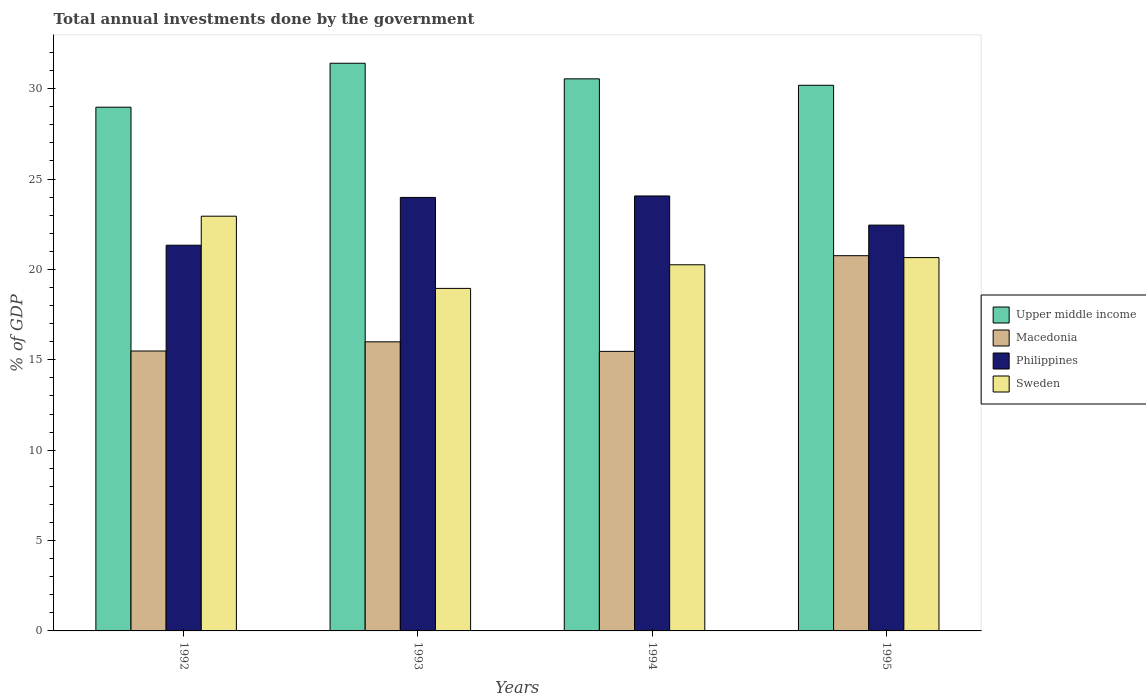How many groups of bars are there?
Provide a succinct answer. 4. Are the number of bars on each tick of the X-axis equal?
Provide a short and direct response. Yes. How many bars are there on the 4th tick from the right?
Your response must be concise. 4. What is the label of the 3rd group of bars from the left?
Your answer should be compact. 1994. What is the total annual investments done by the government in Philippines in 1993?
Make the answer very short. 23.98. Across all years, what is the maximum total annual investments done by the government in Upper middle income?
Offer a very short reply. 31.4. Across all years, what is the minimum total annual investments done by the government in Sweden?
Offer a very short reply. 18.95. In which year was the total annual investments done by the government in Sweden maximum?
Give a very brief answer. 1992. What is the total total annual investments done by the government in Sweden in the graph?
Offer a very short reply. 82.8. What is the difference between the total annual investments done by the government in Upper middle income in 1992 and that in 1994?
Ensure brevity in your answer.  -1.57. What is the difference between the total annual investments done by the government in Sweden in 1993 and the total annual investments done by the government in Upper middle income in 1995?
Keep it short and to the point. -11.24. What is the average total annual investments done by the government in Sweden per year?
Make the answer very short. 20.7. In the year 1995, what is the difference between the total annual investments done by the government in Upper middle income and total annual investments done by the government in Macedonia?
Your answer should be very brief. 9.43. In how many years, is the total annual investments done by the government in Sweden greater than 19 %?
Provide a short and direct response. 3. What is the ratio of the total annual investments done by the government in Macedonia in 1993 to that in 1995?
Provide a succinct answer. 0.77. Is the difference between the total annual investments done by the government in Upper middle income in 1992 and 1993 greater than the difference between the total annual investments done by the government in Macedonia in 1992 and 1993?
Your response must be concise. No. What is the difference between the highest and the second highest total annual investments done by the government in Upper middle income?
Offer a terse response. 0.86. What is the difference between the highest and the lowest total annual investments done by the government in Macedonia?
Make the answer very short. 5.29. In how many years, is the total annual investments done by the government in Upper middle income greater than the average total annual investments done by the government in Upper middle income taken over all years?
Keep it short and to the point. 2. What does the 1st bar from the right in 1992 represents?
Provide a short and direct response. Sweden. Is it the case that in every year, the sum of the total annual investments done by the government in Sweden and total annual investments done by the government in Macedonia is greater than the total annual investments done by the government in Philippines?
Your answer should be very brief. Yes. How many bars are there?
Ensure brevity in your answer.  16. How many years are there in the graph?
Ensure brevity in your answer.  4. What is the difference between two consecutive major ticks on the Y-axis?
Your answer should be compact. 5. Does the graph contain any zero values?
Your answer should be compact. No. What is the title of the graph?
Your answer should be compact. Total annual investments done by the government. What is the label or title of the X-axis?
Your answer should be very brief. Years. What is the label or title of the Y-axis?
Provide a short and direct response. % of GDP. What is the % of GDP of Upper middle income in 1992?
Offer a terse response. 28.97. What is the % of GDP in Macedonia in 1992?
Your answer should be compact. 15.49. What is the % of GDP of Philippines in 1992?
Give a very brief answer. 21.34. What is the % of GDP of Sweden in 1992?
Make the answer very short. 22.94. What is the % of GDP in Upper middle income in 1993?
Offer a terse response. 31.4. What is the % of GDP of Macedonia in 1993?
Your answer should be very brief. 15.99. What is the % of GDP of Philippines in 1993?
Keep it short and to the point. 23.98. What is the % of GDP in Sweden in 1993?
Keep it short and to the point. 18.95. What is the % of GDP of Upper middle income in 1994?
Your response must be concise. 30.54. What is the % of GDP in Macedonia in 1994?
Ensure brevity in your answer.  15.47. What is the % of GDP of Philippines in 1994?
Give a very brief answer. 24.06. What is the % of GDP of Sweden in 1994?
Your answer should be compact. 20.26. What is the % of GDP of Upper middle income in 1995?
Keep it short and to the point. 30.19. What is the % of GDP of Macedonia in 1995?
Offer a very short reply. 20.76. What is the % of GDP of Philippines in 1995?
Provide a short and direct response. 22.45. What is the % of GDP in Sweden in 1995?
Provide a succinct answer. 20.65. Across all years, what is the maximum % of GDP in Upper middle income?
Provide a short and direct response. 31.4. Across all years, what is the maximum % of GDP of Macedonia?
Keep it short and to the point. 20.76. Across all years, what is the maximum % of GDP of Philippines?
Your answer should be compact. 24.06. Across all years, what is the maximum % of GDP of Sweden?
Keep it short and to the point. 22.94. Across all years, what is the minimum % of GDP of Upper middle income?
Your answer should be very brief. 28.97. Across all years, what is the minimum % of GDP of Macedonia?
Your response must be concise. 15.47. Across all years, what is the minimum % of GDP in Philippines?
Your answer should be compact. 21.34. Across all years, what is the minimum % of GDP in Sweden?
Ensure brevity in your answer.  18.95. What is the total % of GDP in Upper middle income in the graph?
Give a very brief answer. 121.11. What is the total % of GDP of Macedonia in the graph?
Keep it short and to the point. 67.7. What is the total % of GDP of Philippines in the graph?
Your response must be concise. 91.83. What is the total % of GDP in Sweden in the graph?
Keep it short and to the point. 82.8. What is the difference between the % of GDP of Upper middle income in 1992 and that in 1993?
Your answer should be compact. -2.43. What is the difference between the % of GDP in Macedonia in 1992 and that in 1993?
Provide a succinct answer. -0.51. What is the difference between the % of GDP of Philippines in 1992 and that in 1993?
Offer a terse response. -2.64. What is the difference between the % of GDP of Sweden in 1992 and that in 1993?
Offer a very short reply. 4. What is the difference between the % of GDP in Upper middle income in 1992 and that in 1994?
Provide a succinct answer. -1.57. What is the difference between the % of GDP in Macedonia in 1992 and that in 1994?
Offer a terse response. 0.02. What is the difference between the % of GDP in Philippines in 1992 and that in 1994?
Your answer should be compact. -2.72. What is the difference between the % of GDP in Sweden in 1992 and that in 1994?
Your response must be concise. 2.69. What is the difference between the % of GDP in Upper middle income in 1992 and that in 1995?
Make the answer very short. -1.21. What is the difference between the % of GDP in Macedonia in 1992 and that in 1995?
Keep it short and to the point. -5.27. What is the difference between the % of GDP in Philippines in 1992 and that in 1995?
Make the answer very short. -1.11. What is the difference between the % of GDP in Sweden in 1992 and that in 1995?
Give a very brief answer. 2.29. What is the difference between the % of GDP of Upper middle income in 1993 and that in 1994?
Give a very brief answer. 0.86. What is the difference between the % of GDP of Macedonia in 1993 and that in 1994?
Provide a succinct answer. 0.53. What is the difference between the % of GDP in Philippines in 1993 and that in 1994?
Keep it short and to the point. -0.08. What is the difference between the % of GDP of Sweden in 1993 and that in 1994?
Make the answer very short. -1.31. What is the difference between the % of GDP in Upper middle income in 1993 and that in 1995?
Offer a terse response. 1.22. What is the difference between the % of GDP in Macedonia in 1993 and that in 1995?
Provide a short and direct response. -4.76. What is the difference between the % of GDP in Philippines in 1993 and that in 1995?
Keep it short and to the point. 1.53. What is the difference between the % of GDP of Sweden in 1993 and that in 1995?
Provide a succinct answer. -1.7. What is the difference between the % of GDP in Upper middle income in 1994 and that in 1995?
Your response must be concise. 0.36. What is the difference between the % of GDP of Macedonia in 1994 and that in 1995?
Give a very brief answer. -5.29. What is the difference between the % of GDP in Philippines in 1994 and that in 1995?
Provide a short and direct response. 1.61. What is the difference between the % of GDP in Sweden in 1994 and that in 1995?
Your response must be concise. -0.4. What is the difference between the % of GDP in Upper middle income in 1992 and the % of GDP in Macedonia in 1993?
Your answer should be compact. 12.98. What is the difference between the % of GDP in Upper middle income in 1992 and the % of GDP in Philippines in 1993?
Offer a terse response. 4.99. What is the difference between the % of GDP in Upper middle income in 1992 and the % of GDP in Sweden in 1993?
Your answer should be very brief. 10.02. What is the difference between the % of GDP of Macedonia in 1992 and the % of GDP of Philippines in 1993?
Make the answer very short. -8.5. What is the difference between the % of GDP of Macedonia in 1992 and the % of GDP of Sweden in 1993?
Ensure brevity in your answer.  -3.46. What is the difference between the % of GDP in Philippines in 1992 and the % of GDP in Sweden in 1993?
Provide a succinct answer. 2.39. What is the difference between the % of GDP of Upper middle income in 1992 and the % of GDP of Macedonia in 1994?
Your answer should be compact. 13.51. What is the difference between the % of GDP of Upper middle income in 1992 and the % of GDP of Philippines in 1994?
Provide a short and direct response. 4.91. What is the difference between the % of GDP in Upper middle income in 1992 and the % of GDP in Sweden in 1994?
Keep it short and to the point. 8.72. What is the difference between the % of GDP of Macedonia in 1992 and the % of GDP of Philippines in 1994?
Provide a succinct answer. -8.58. What is the difference between the % of GDP in Macedonia in 1992 and the % of GDP in Sweden in 1994?
Make the answer very short. -4.77. What is the difference between the % of GDP in Philippines in 1992 and the % of GDP in Sweden in 1994?
Offer a terse response. 1.08. What is the difference between the % of GDP in Upper middle income in 1992 and the % of GDP in Macedonia in 1995?
Give a very brief answer. 8.21. What is the difference between the % of GDP of Upper middle income in 1992 and the % of GDP of Philippines in 1995?
Your answer should be very brief. 6.52. What is the difference between the % of GDP in Upper middle income in 1992 and the % of GDP in Sweden in 1995?
Offer a terse response. 8.32. What is the difference between the % of GDP of Macedonia in 1992 and the % of GDP of Philippines in 1995?
Your response must be concise. -6.97. What is the difference between the % of GDP in Macedonia in 1992 and the % of GDP in Sweden in 1995?
Provide a succinct answer. -5.17. What is the difference between the % of GDP in Philippines in 1992 and the % of GDP in Sweden in 1995?
Make the answer very short. 0.68. What is the difference between the % of GDP of Upper middle income in 1993 and the % of GDP of Macedonia in 1994?
Give a very brief answer. 15.94. What is the difference between the % of GDP of Upper middle income in 1993 and the % of GDP of Philippines in 1994?
Ensure brevity in your answer.  7.34. What is the difference between the % of GDP in Upper middle income in 1993 and the % of GDP in Sweden in 1994?
Give a very brief answer. 11.15. What is the difference between the % of GDP in Macedonia in 1993 and the % of GDP in Philippines in 1994?
Your answer should be compact. -8.07. What is the difference between the % of GDP of Macedonia in 1993 and the % of GDP of Sweden in 1994?
Your answer should be very brief. -4.26. What is the difference between the % of GDP in Philippines in 1993 and the % of GDP in Sweden in 1994?
Give a very brief answer. 3.73. What is the difference between the % of GDP of Upper middle income in 1993 and the % of GDP of Macedonia in 1995?
Offer a terse response. 10.65. What is the difference between the % of GDP of Upper middle income in 1993 and the % of GDP of Philippines in 1995?
Make the answer very short. 8.95. What is the difference between the % of GDP in Upper middle income in 1993 and the % of GDP in Sweden in 1995?
Ensure brevity in your answer.  10.75. What is the difference between the % of GDP in Macedonia in 1993 and the % of GDP in Philippines in 1995?
Provide a short and direct response. -6.46. What is the difference between the % of GDP of Macedonia in 1993 and the % of GDP of Sweden in 1995?
Offer a terse response. -4.66. What is the difference between the % of GDP of Philippines in 1993 and the % of GDP of Sweden in 1995?
Your response must be concise. 3.33. What is the difference between the % of GDP of Upper middle income in 1994 and the % of GDP of Macedonia in 1995?
Provide a short and direct response. 9.78. What is the difference between the % of GDP of Upper middle income in 1994 and the % of GDP of Philippines in 1995?
Ensure brevity in your answer.  8.09. What is the difference between the % of GDP of Upper middle income in 1994 and the % of GDP of Sweden in 1995?
Ensure brevity in your answer.  9.89. What is the difference between the % of GDP of Macedonia in 1994 and the % of GDP of Philippines in 1995?
Provide a short and direct response. -6.98. What is the difference between the % of GDP of Macedonia in 1994 and the % of GDP of Sweden in 1995?
Make the answer very short. -5.19. What is the difference between the % of GDP in Philippines in 1994 and the % of GDP in Sweden in 1995?
Ensure brevity in your answer.  3.41. What is the average % of GDP in Upper middle income per year?
Provide a short and direct response. 30.28. What is the average % of GDP in Macedonia per year?
Make the answer very short. 16.93. What is the average % of GDP of Philippines per year?
Ensure brevity in your answer.  22.96. What is the average % of GDP of Sweden per year?
Your answer should be very brief. 20.7. In the year 1992, what is the difference between the % of GDP of Upper middle income and % of GDP of Macedonia?
Give a very brief answer. 13.49. In the year 1992, what is the difference between the % of GDP in Upper middle income and % of GDP in Philippines?
Offer a terse response. 7.63. In the year 1992, what is the difference between the % of GDP of Upper middle income and % of GDP of Sweden?
Give a very brief answer. 6.03. In the year 1992, what is the difference between the % of GDP in Macedonia and % of GDP in Philippines?
Offer a very short reply. -5.85. In the year 1992, what is the difference between the % of GDP of Macedonia and % of GDP of Sweden?
Keep it short and to the point. -7.46. In the year 1992, what is the difference between the % of GDP in Philippines and % of GDP in Sweden?
Offer a very short reply. -1.61. In the year 1993, what is the difference between the % of GDP in Upper middle income and % of GDP in Macedonia?
Your answer should be compact. 15.41. In the year 1993, what is the difference between the % of GDP of Upper middle income and % of GDP of Philippines?
Your answer should be very brief. 7.42. In the year 1993, what is the difference between the % of GDP in Upper middle income and % of GDP in Sweden?
Provide a succinct answer. 12.46. In the year 1993, what is the difference between the % of GDP in Macedonia and % of GDP in Philippines?
Provide a succinct answer. -7.99. In the year 1993, what is the difference between the % of GDP of Macedonia and % of GDP of Sweden?
Ensure brevity in your answer.  -2.96. In the year 1993, what is the difference between the % of GDP in Philippines and % of GDP in Sweden?
Your response must be concise. 5.03. In the year 1994, what is the difference between the % of GDP of Upper middle income and % of GDP of Macedonia?
Make the answer very short. 15.08. In the year 1994, what is the difference between the % of GDP in Upper middle income and % of GDP in Philippines?
Provide a short and direct response. 6.48. In the year 1994, what is the difference between the % of GDP of Upper middle income and % of GDP of Sweden?
Provide a short and direct response. 10.29. In the year 1994, what is the difference between the % of GDP in Macedonia and % of GDP in Philippines?
Your answer should be compact. -8.6. In the year 1994, what is the difference between the % of GDP of Macedonia and % of GDP of Sweden?
Your response must be concise. -4.79. In the year 1994, what is the difference between the % of GDP of Philippines and % of GDP of Sweden?
Your answer should be compact. 3.81. In the year 1995, what is the difference between the % of GDP of Upper middle income and % of GDP of Macedonia?
Ensure brevity in your answer.  9.43. In the year 1995, what is the difference between the % of GDP of Upper middle income and % of GDP of Philippines?
Provide a short and direct response. 7.74. In the year 1995, what is the difference between the % of GDP in Upper middle income and % of GDP in Sweden?
Give a very brief answer. 9.53. In the year 1995, what is the difference between the % of GDP in Macedonia and % of GDP in Philippines?
Provide a succinct answer. -1.69. In the year 1995, what is the difference between the % of GDP in Macedonia and % of GDP in Sweden?
Ensure brevity in your answer.  0.1. In the year 1995, what is the difference between the % of GDP of Philippines and % of GDP of Sweden?
Give a very brief answer. 1.8. What is the ratio of the % of GDP in Upper middle income in 1992 to that in 1993?
Provide a short and direct response. 0.92. What is the ratio of the % of GDP in Macedonia in 1992 to that in 1993?
Your answer should be very brief. 0.97. What is the ratio of the % of GDP of Philippines in 1992 to that in 1993?
Provide a succinct answer. 0.89. What is the ratio of the % of GDP in Sweden in 1992 to that in 1993?
Offer a terse response. 1.21. What is the ratio of the % of GDP in Upper middle income in 1992 to that in 1994?
Your answer should be very brief. 0.95. What is the ratio of the % of GDP of Macedonia in 1992 to that in 1994?
Offer a terse response. 1. What is the ratio of the % of GDP in Philippines in 1992 to that in 1994?
Keep it short and to the point. 0.89. What is the ratio of the % of GDP in Sweden in 1992 to that in 1994?
Provide a short and direct response. 1.13. What is the ratio of the % of GDP of Upper middle income in 1992 to that in 1995?
Ensure brevity in your answer.  0.96. What is the ratio of the % of GDP in Macedonia in 1992 to that in 1995?
Offer a very short reply. 0.75. What is the ratio of the % of GDP in Philippines in 1992 to that in 1995?
Provide a short and direct response. 0.95. What is the ratio of the % of GDP of Sweden in 1992 to that in 1995?
Provide a short and direct response. 1.11. What is the ratio of the % of GDP in Upper middle income in 1993 to that in 1994?
Give a very brief answer. 1.03. What is the ratio of the % of GDP of Macedonia in 1993 to that in 1994?
Keep it short and to the point. 1.03. What is the ratio of the % of GDP in Philippines in 1993 to that in 1994?
Your answer should be very brief. 1. What is the ratio of the % of GDP in Sweden in 1993 to that in 1994?
Make the answer very short. 0.94. What is the ratio of the % of GDP of Upper middle income in 1993 to that in 1995?
Ensure brevity in your answer.  1.04. What is the ratio of the % of GDP in Macedonia in 1993 to that in 1995?
Keep it short and to the point. 0.77. What is the ratio of the % of GDP in Philippines in 1993 to that in 1995?
Offer a very short reply. 1.07. What is the ratio of the % of GDP of Sweden in 1993 to that in 1995?
Your answer should be very brief. 0.92. What is the ratio of the % of GDP of Upper middle income in 1994 to that in 1995?
Your response must be concise. 1.01. What is the ratio of the % of GDP in Macedonia in 1994 to that in 1995?
Your response must be concise. 0.74. What is the ratio of the % of GDP in Philippines in 1994 to that in 1995?
Offer a very short reply. 1.07. What is the ratio of the % of GDP in Sweden in 1994 to that in 1995?
Your answer should be very brief. 0.98. What is the difference between the highest and the second highest % of GDP of Upper middle income?
Offer a very short reply. 0.86. What is the difference between the highest and the second highest % of GDP in Macedonia?
Keep it short and to the point. 4.76. What is the difference between the highest and the second highest % of GDP of Philippines?
Your response must be concise. 0.08. What is the difference between the highest and the second highest % of GDP in Sweden?
Make the answer very short. 2.29. What is the difference between the highest and the lowest % of GDP in Upper middle income?
Your answer should be compact. 2.43. What is the difference between the highest and the lowest % of GDP of Macedonia?
Make the answer very short. 5.29. What is the difference between the highest and the lowest % of GDP of Philippines?
Make the answer very short. 2.72. What is the difference between the highest and the lowest % of GDP in Sweden?
Keep it short and to the point. 4. 